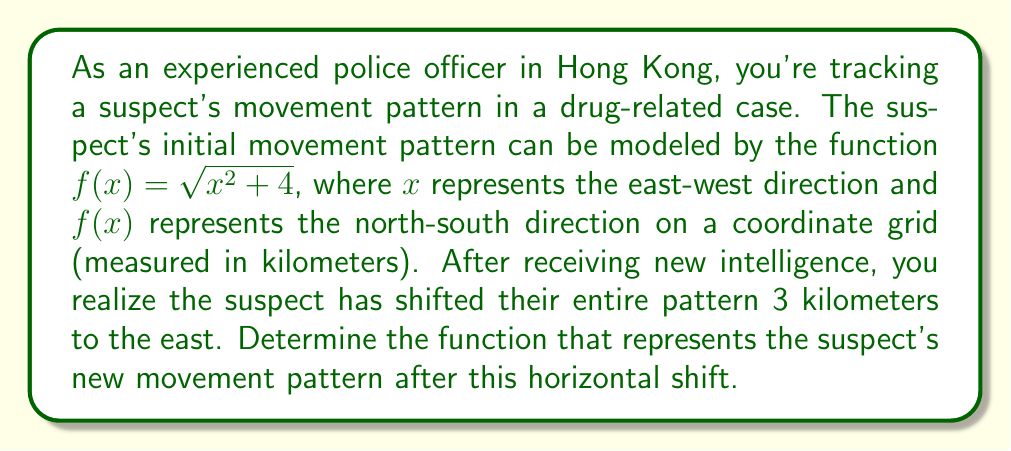Could you help me with this problem? To solve this problem, we need to apply a horizontal shift to the original function. The general form for a horizontal shift is:

If $y = f(x)$ is shifted $h$ units to the right, the new function is $y = f(x - h)$
If $y = f(x)$ is shifted $h$ units to the left, the new function is $y = f(x + h)$

In this case, the suspect has moved 3 kilometers to the east, which is equivalent to shifting the function 3 units to the right on the coordinate grid. Therefore, we need to replace $x$ with $(x - 3)$ in the original function.

The original function is:
$f(x) = \sqrt{x^2 + 4}$

Applying the horizontal shift:
$g(x) = f(x - 3) = \sqrt{(x - 3)^2 + 4}$

This new function $g(x)$ represents the suspect's movement pattern after shifting 3 kilometers to the east.
Answer: The function representing the suspect's new movement pattern after shifting 3 kilometers to the east is:

$g(x) = \sqrt{(x - 3)^2 + 4}$ 